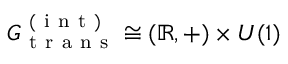<formula> <loc_0><loc_0><loc_500><loc_500>G _ { t r a n s } ^ { ( i n t ) } \cong ( \mathbb { R } , + ) \times U ( 1 )</formula> 